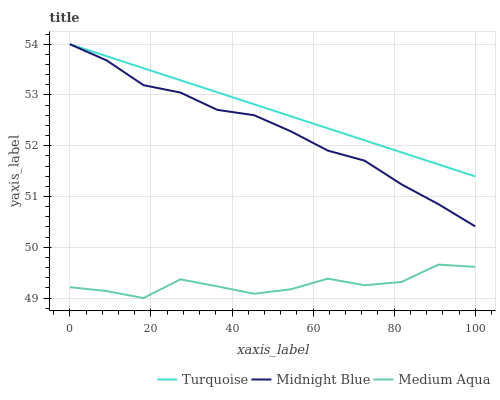Does Medium Aqua have the minimum area under the curve?
Answer yes or no. Yes. Does Turquoise have the maximum area under the curve?
Answer yes or no. Yes. Does Midnight Blue have the minimum area under the curve?
Answer yes or no. No. Does Midnight Blue have the maximum area under the curve?
Answer yes or no. No. Is Turquoise the smoothest?
Answer yes or no. Yes. Is Medium Aqua the roughest?
Answer yes or no. Yes. Is Midnight Blue the smoothest?
Answer yes or no. No. Is Midnight Blue the roughest?
Answer yes or no. No. Does Medium Aqua have the lowest value?
Answer yes or no. Yes. Does Midnight Blue have the lowest value?
Answer yes or no. No. Does Midnight Blue have the highest value?
Answer yes or no. Yes. Does Medium Aqua have the highest value?
Answer yes or no. No. Is Medium Aqua less than Turquoise?
Answer yes or no. Yes. Is Midnight Blue greater than Medium Aqua?
Answer yes or no. Yes. Does Midnight Blue intersect Turquoise?
Answer yes or no. Yes. Is Midnight Blue less than Turquoise?
Answer yes or no. No. Is Midnight Blue greater than Turquoise?
Answer yes or no. No. Does Medium Aqua intersect Turquoise?
Answer yes or no. No. 